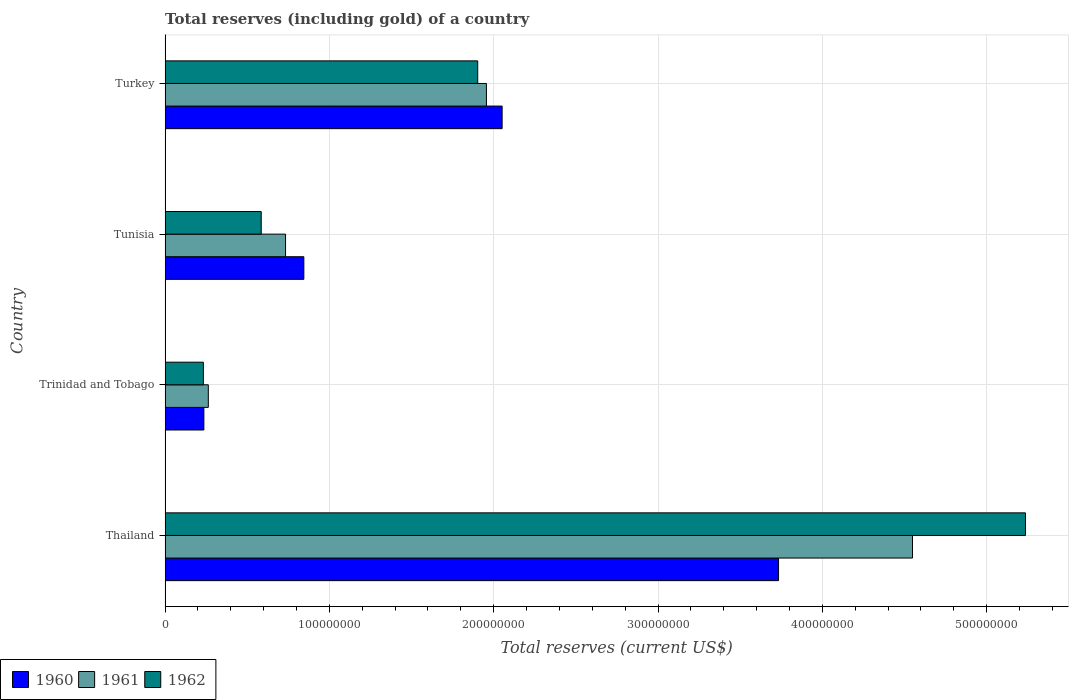Are the number of bars per tick equal to the number of legend labels?
Provide a short and direct response. Yes. Are the number of bars on each tick of the Y-axis equal?
Provide a succinct answer. Yes. How many bars are there on the 1st tick from the top?
Make the answer very short. 3. How many bars are there on the 3rd tick from the bottom?
Provide a short and direct response. 3. What is the label of the 3rd group of bars from the top?
Your answer should be very brief. Trinidad and Tobago. What is the total reserves (including gold) in 1962 in Trinidad and Tobago?
Your answer should be very brief. 2.33e+07. Across all countries, what is the maximum total reserves (including gold) in 1962?
Make the answer very short. 5.24e+08. Across all countries, what is the minimum total reserves (including gold) in 1961?
Ensure brevity in your answer.  2.63e+07. In which country was the total reserves (including gold) in 1962 maximum?
Offer a terse response. Thailand. In which country was the total reserves (including gold) in 1960 minimum?
Your answer should be very brief. Trinidad and Tobago. What is the total total reserves (including gold) in 1962 in the graph?
Your response must be concise. 7.96e+08. What is the difference between the total reserves (including gold) in 1962 in Thailand and that in Trinidad and Tobago?
Your answer should be very brief. 5.00e+08. What is the difference between the total reserves (including gold) in 1961 in Trinidad and Tobago and the total reserves (including gold) in 1960 in Turkey?
Offer a terse response. -1.79e+08. What is the average total reserves (including gold) in 1961 per country?
Offer a terse response. 1.88e+08. What is the ratio of the total reserves (including gold) in 1960 in Trinidad and Tobago to that in Turkey?
Make the answer very short. 0.12. Is the difference between the total reserves (including gold) in 1960 in Thailand and Trinidad and Tobago greater than the difference between the total reserves (including gold) in 1962 in Thailand and Trinidad and Tobago?
Offer a very short reply. No. What is the difference between the highest and the second highest total reserves (including gold) in 1961?
Provide a short and direct response. 2.59e+08. What is the difference between the highest and the lowest total reserves (including gold) in 1961?
Your answer should be compact. 4.29e+08. In how many countries, is the total reserves (including gold) in 1960 greater than the average total reserves (including gold) in 1960 taken over all countries?
Provide a succinct answer. 2. What does the 1st bar from the top in Tunisia represents?
Keep it short and to the point. 1962. What does the 1st bar from the bottom in Trinidad and Tobago represents?
Make the answer very short. 1960. Is it the case that in every country, the sum of the total reserves (including gold) in 1961 and total reserves (including gold) in 1962 is greater than the total reserves (including gold) in 1960?
Provide a succinct answer. Yes. How many countries are there in the graph?
Your response must be concise. 4. Does the graph contain grids?
Your answer should be very brief. Yes. Where does the legend appear in the graph?
Ensure brevity in your answer.  Bottom left. What is the title of the graph?
Offer a terse response. Total reserves (including gold) of a country. Does "1969" appear as one of the legend labels in the graph?
Provide a short and direct response. No. What is the label or title of the X-axis?
Keep it short and to the point. Total reserves (current US$). What is the Total reserves (current US$) in 1960 in Thailand?
Your answer should be very brief. 3.73e+08. What is the Total reserves (current US$) of 1961 in Thailand?
Keep it short and to the point. 4.55e+08. What is the Total reserves (current US$) of 1962 in Thailand?
Make the answer very short. 5.24e+08. What is the Total reserves (current US$) of 1960 in Trinidad and Tobago?
Keep it short and to the point. 2.36e+07. What is the Total reserves (current US$) of 1961 in Trinidad and Tobago?
Make the answer very short. 2.63e+07. What is the Total reserves (current US$) in 1962 in Trinidad and Tobago?
Your answer should be very brief. 2.33e+07. What is the Total reserves (current US$) in 1960 in Tunisia?
Your answer should be very brief. 8.45e+07. What is the Total reserves (current US$) in 1961 in Tunisia?
Offer a very short reply. 7.33e+07. What is the Total reserves (current US$) of 1962 in Tunisia?
Give a very brief answer. 5.85e+07. What is the Total reserves (current US$) in 1960 in Turkey?
Your response must be concise. 2.05e+08. What is the Total reserves (current US$) in 1961 in Turkey?
Your answer should be compact. 1.96e+08. What is the Total reserves (current US$) in 1962 in Turkey?
Offer a very short reply. 1.90e+08. Across all countries, what is the maximum Total reserves (current US$) in 1960?
Your response must be concise. 3.73e+08. Across all countries, what is the maximum Total reserves (current US$) in 1961?
Offer a terse response. 4.55e+08. Across all countries, what is the maximum Total reserves (current US$) of 1962?
Provide a succinct answer. 5.24e+08. Across all countries, what is the minimum Total reserves (current US$) of 1960?
Your response must be concise. 2.36e+07. Across all countries, what is the minimum Total reserves (current US$) in 1961?
Offer a very short reply. 2.63e+07. Across all countries, what is the minimum Total reserves (current US$) in 1962?
Offer a very short reply. 2.33e+07. What is the total Total reserves (current US$) of 1960 in the graph?
Your answer should be compact. 6.87e+08. What is the total Total reserves (current US$) in 1961 in the graph?
Ensure brevity in your answer.  7.50e+08. What is the total Total reserves (current US$) in 1962 in the graph?
Your response must be concise. 7.96e+08. What is the difference between the Total reserves (current US$) in 1960 in Thailand and that in Trinidad and Tobago?
Provide a succinct answer. 3.50e+08. What is the difference between the Total reserves (current US$) of 1961 in Thailand and that in Trinidad and Tobago?
Give a very brief answer. 4.29e+08. What is the difference between the Total reserves (current US$) in 1962 in Thailand and that in Trinidad and Tobago?
Provide a short and direct response. 5.00e+08. What is the difference between the Total reserves (current US$) of 1960 in Thailand and that in Tunisia?
Your response must be concise. 2.89e+08. What is the difference between the Total reserves (current US$) of 1961 in Thailand and that in Tunisia?
Your response must be concise. 3.82e+08. What is the difference between the Total reserves (current US$) in 1962 in Thailand and that in Tunisia?
Give a very brief answer. 4.65e+08. What is the difference between the Total reserves (current US$) of 1960 in Thailand and that in Turkey?
Provide a short and direct response. 1.68e+08. What is the difference between the Total reserves (current US$) in 1961 in Thailand and that in Turkey?
Your answer should be compact. 2.59e+08. What is the difference between the Total reserves (current US$) of 1962 in Thailand and that in Turkey?
Provide a short and direct response. 3.33e+08. What is the difference between the Total reserves (current US$) in 1960 in Trinidad and Tobago and that in Tunisia?
Your answer should be compact. -6.09e+07. What is the difference between the Total reserves (current US$) in 1961 in Trinidad and Tobago and that in Tunisia?
Offer a terse response. -4.70e+07. What is the difference between the Total reserves (current US$) of 1962 in Trinidad and Tobago and that in Tunisia?
Make the answer very short. -3.52e+07. What is the difference between the Total reserves (current US$) in 1960 in Trinidad and Tobago and that in Turkey?
Your answer should be compact. -1.82e+08. What is the difference between the Total reserves (current US$) in 1961 in Trinidad and Tobago and that in Turkey?
Your response must be concise. -1.69e+08. What is the difference between the Total reserves (current US$) of 1962 in Trinidad and Tobago and that in Turkey?
Ensure brevity in your answer.  -1.67e+08. What is the difference between the Total reserves (current US$) of 1960 in Tunisia and that in Turkey?
Your answer should be very brief. -1.21e+08. What is the difference between the Total reserves (current US$) of 1961 in Tunisia and that in Turkey?
Give a very brief answer. -1.22e+08. What is the difference between the Total reserves (current US$) in 1962 in Tunisia and that in Turkey?
Make the answer very short. -1.32e+08. What is the difference between the Total reserves (current US$) of 1960 in Thailand and the Total reserves (current US$) of 1961 in Trinidad and Tobago?
Offer a very short reply. 3.47e+08. What is the difference between the Total reserves (current US$) in 1960 in Thailand and the Total reserves (current US$) in 1962 in Trinidad and Tobago?
Offer a very short reply. 3.50e+08. What is the difference between the Total reserves (current US$) of 1961 in Thailand and the Total reserves (current US$) of 1962 in Trinidad and Tobago?
Offer a terse response. 4.32e+08. What is the difference between the Total reserves (current US$) of 1960 in Thailand and the Total reserves (current US$) of 1961 in Tunisia?
Ensure brevity in your answer.  3.00e+08. What is the difference between the Total reserves (current US$) in 1960 in Thailand and the Total reserves (current US$) in 1962 in Tunisia?
Your response must be concise. 3.15e+08. What is the difference between the Total reserves (current US$) of 1961 in Thailand and the Total reserves (current US$) of 1962 in Tunisia?
Make the answer very short. 3.96e+08. What is the difference between the Total reserves (current US$) of 1960 in Thailand and the Total reserves (current US$) of 1961 in Turkey?
Provide a short and direct response. 1.78e+08. What is the difference between the Total reserves (current US$) of 1960 in Thailand and the Total reserves (current US$) of 1962 in Turkey?
Provide a short and direct response. 1.83e+08. What is the difference between the Total reserves (current US$) in 1961 in Thailand and the Total reserves (current US$) in 1962 in Turkey?
Provide a short and direct response. 2.65e+08. What is the difference between the Total reserves (current US$) of 1960 in Trinidad and Tobago and the Total reserves (current US$) of 1961 in Tunisia?
Your response must be concise. -4.97e+07. What is the difference between the Total reserves (current US$) of 1960 in Trinidad and Tobago and the Total reserves (current US$) of 1962 in Tunisia?
Keep it short and to the point. -3.49e+07. What is the difference between the Total reserves (current US$) of 1961 in Trinidad and Tobago and the Total reserves (current US$) of 1962 in Tunisia?
Ensure brevity in your answer.  -3.22e+07. What is the difference between the Total reserves (current US$) in 1960 in Trinidad and Tobago and the Total reserves (current US$) in 1961 in Turkey?
Keep it short and to the point. -1.72e+08. What is the difference between the Total reserves (current US$) of 1960 in Trinidad and Tobago and the Total reserves (current US$) of 1962 in Turkey?
Offer a terse response. -1.67e+08. What is the difference between the Total reserves (current US$) in 1961 in Trinidad and Tobago and the Total reserves (current US$) in 1962 in Turkey?
Your answer should be compact. -1.64e+08. What is the difference between the Total reserves (current US$) of 1960 in Tunisia and the Total reserves (current US$) of 1961 in Turkey?
Ensure brevity in your answer.  -1.11e+08. What is the difference between the Total reserves (current US$) in 1960 in Tunisia and the Total reserves (current US$) in 1962 in Turkey?
Offer a terse response. -1.06e+08. What is the difference between the Total reserves (current US$) in 1961 in Tunisia and the Total reserves (current US$) in 1962 in Turkey?
Provide a succinct answer. -1.17e+08. What is the average Total reserves (current US$) of 1960 per country?
Provide a succinct answer. 1.72e+08. What is the average Total reserves (current US$) of 1961 per country?
Provide a short and direct response. 1.88e+08. What is the average Total reserves (current US$) in 1962 per country?
Make the answer very short. 1.99e+08. What is the difference between the Total reserves (current US$) in 1960 and Total reserves (current US$) in 1961 in Thailand?
Ensure brevity in your answer.  -8.15e+07. What is the difference between the Total reserves (current US$) of 1960 and Total reserves (current US$) of 1962 in Thailand?
Ensure brevity in your answer.  -1.50e+08. What is the difference between the Total reserves (current US$) in 1961 and Total reserves (current US$) in 1962 in Thailand?
Your answer should be very brief. -6.88e+07. What is the difference between the Total reserves (current US$) of 1960 and Total reserves (current US$) of 1961 in Trinidad and Tobago?
Ensure brevity in your answer.  -2.70e+06. What is the difference between the Total reserves (current US$) in 1960 and Total reserves (current US$) in 1962 in Trinidad and Tobago?
Your answer should be very brief. 3.00e+05. What is the difference between the Total reserves (current US$) of 1961 and Total reserves (current US$) of 1962 in Trinidad and Tobago?
Make the answer very short. 3.00e+06. What is the difference between the Total reserves (current US$) in 1960 and Total reserves (current US$) in 1961 in Tunisia?
Make the answer very short. 1.11e+07. What is the difference between the Total reserves (current US$) of 1960 and Total reserves (current US$) of 1962 in Tunisia?
Ensure brevity in your answer.  2.59e+07. What is the difference between the Total reserves (current US$) in 1961 and Total reserves (current US$) in 1962 in Tunisia?
Ensure brevity in your answer.  1.48e+07. What is the difference between the Total reserves (current US$) in 1960 and Total reserves (current US$) in 1961 in Turkey?
Make the answer very short. 9.56e+06. What is the difference between the Total reserves (current US$) of 1960 and Total reserves (current US$) of 1962 in Turkey?
Offer a very short reply. 1.48e+07. What is the difference between the Total reserves (current US$) in 1961 and Total reserves (current US$) in 1962 in Turkey?
Provide a short and direct response. 5.29e+06. What is the ratio of the Total reserves (current US$) in 1960 in Thailand to that in Trinidad and Tobago?
Make the answer very short. 15.82. What is the ratio of the Total reserves (current US$) of 1961 in Thailand to that in Trinidad and Tobago?
Make the answer very short. 17.3. What is the ratio of the Total reserves (current US$) in 1962 in Thailand to that in Trinidad and Tobago?
Your response must be concise. 22.47. What is the ratio of the Total reserves (current US$) in 1960 in Thailand to that in Tunisia?
Ensure brevity in your answer.  4.42. What is the ratio of the Total reserves (current US$) in 1961 in Thailand to that in Tunisia?
Your answer should be very brief. 6.2. What is the ratio of the Total reserves (current US$) in 1962 in Thailand to that in Tunisia?
Your response must be concise. 8.95. What is the ratio of the Total reserves (current US$) of 1960 in Thailand to that in Turkey?
Offer a terse response. 1.82. What is the ratio of the Total reserves (current US$) in 1961 in Thailand to that in Turkey?
Provide a short and direct response. 2.33. What is the ratio of the Total reserves (current US$) of 1962 in Thailand to that in Turkey?
Your response must be concise. 2.75. What is the ratio of the Total reserves (current US$) in 1960 in Trinidad and Tobago to that in Tunisia?
Ensure brevity in your answer.  0.28. What is the ratio of the Total reserves (current US$) of 1961 in Trinidad and Tobago to that in Tunisia?
Ensure brevity in your answer.  0.36. What is the ratio of the Total reserves (current US$) of 1962 in Trinidad and Tobago to that in Tunisia?
Give a very brief answer. 0.4. What is the ratio of the Total reserves (current US$) in 1960 in Trinidad and Tobago to that in Turkey?
Your answer should be very brief. 0.12. What is the ratio of the Total reserves (current US$) of 1961 in Trinidad and Tobago to that in Turkey?
Ensure brevity in your answer.  0.13. What is the ratio of the Total reserves (current US$) of 1962 in Trinidad and Tobago to that in Turkey?
Your answer should be very brief. 0.12. What is the ratio of the Total reserves (current US$) in 1960 in Tunisia to that in Turkey?
Your response must be concise. 0.41. What is the ratio of the Total reserves (current US$) in 1961 in Tunisia to that in Turkey?
Your answer should be very brief. 0.37. What is the ratio of the Total reserves (current US$) of 1962 in Tunisia to that in Turkey?
Your response must be concise. 0.31. What is the difference between the highest and the second highest Total reserves (current US$) in 1960?
Offer a terse response. 1.68e+08. What is the difference between the highest and the second highest Total reserves (current US$) in 1961?
Offer a very short reply. 2.59e+08. What is the difference between the highest and the second highest Total reserves (current US$) in 1962?
Make the answer very short. 3.33e+08. What is the difference between the highest and the lowest Total reserves (current US$) in 1960?
Your answer should be very brief. 3.50e+08. What is the difference between the highest and the lowest Total reserves (current US$) in 1961?
Give a very brief answer. 4.29e+08. What is the difference between the highest and the lowest Total reserves (current US$) of 1962?
Your answer should be very brief. 5.00e+08. 